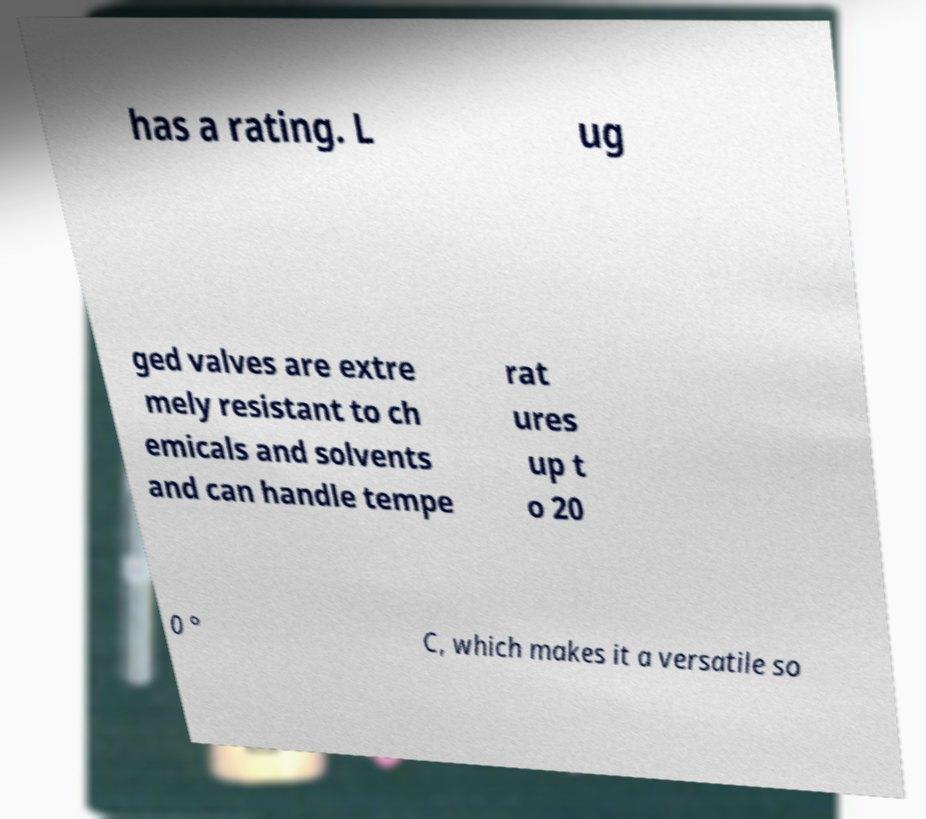There's text embedded in this image that I need extracted. Can you transcribe it verbatim? has a rating. L ug ged valves are extre mely resistant to ch emicals and solvents and can handle tempe rat ures up t o 20 0 ° C, which makes it a versatile so 